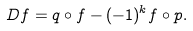Convert formula to latex. <formula><loc_0><loc_0><loc_500><loc_500>D f = q \circ f - ( - 1 ) ^ { k } f \circ p .</formula> 